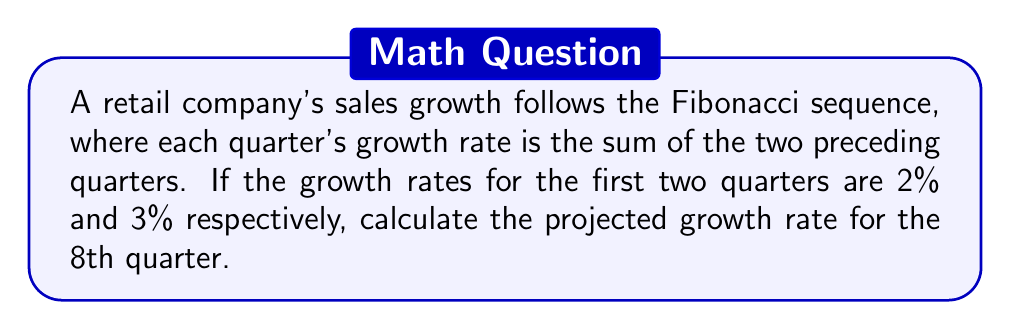Solve this math problem. Let's approach this step-by-step:

1) First, recall the Fibonacci sequence formula:
   $F_n = F_{n-1} + F_{n-2}$, where $F_n$ is the nth term in the sequence.

2) We're given the first two terms:
   $F_1 = 2\%$
   $F_2 = 3\%$

3) Let's calculate the subsequent terms:
   $F_3 = F_2 + F_1 = 3\% + 2\% = 5\%$
   $F_4 = F_3 + F_2 = 5\% + 3\% = 8\%$
   $F_5 = F_4 + F_3 = 8\% + 5\% = 13\%$
   $F_6 = F_5 + F_4 = 13\% + 8\% = 21\%$
   $F_7 = F_6 + F_5 = 21\% + 13\% = 34\%$
   $F_8 = F_7 + F_6 = 34\% + 21\% = 55\%$

4) Therefore, the projected growth rate for the 8th quarter is 55%.

This sequence can also be represented by the closed-form formula:

$$F_n = \frac{\phi^n - (-\phi)^{-n}}{\sqrt{5}}$$

Where $\phi = \frac{1+\sqrt{5}}{2}$ is the golden ratio. However, for small n, the iterative method is usually simpler.
Answer: 55% 